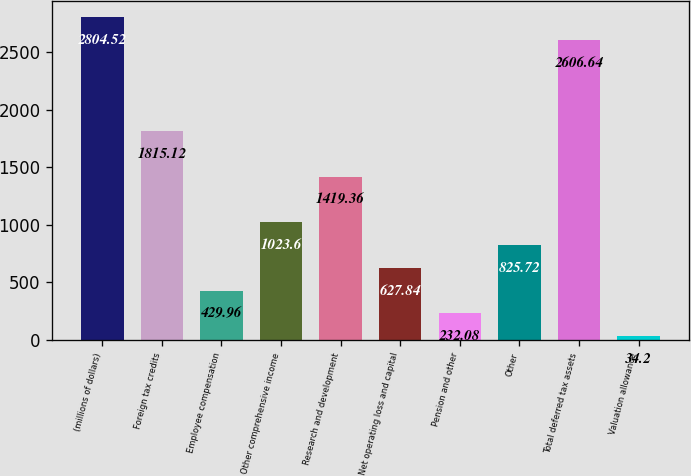Convert chart to OTSL. <chart><loc_0><loc_0><loc_500><loc_500><bar_chart><fcel>(millions of dollars)<fcel>Foreign tax credits<fcel>Employee compensation<fcel>Other comprehensive income<fcel>Research and development<fcel>Net operating loss and capital<fcel>Pension and other<fcel>Other<fcel>Total deferred tax assets<fcel>Valuation allowance<nl><fcel>2804.52<fcel>1815.12<fcel>429.96<fcel>1023.6<fcel>1419.36<fcel>627.84<fcel>232.08<fcel>825.72<fcel>2606.64<fcel>34.2<nl></chart> 